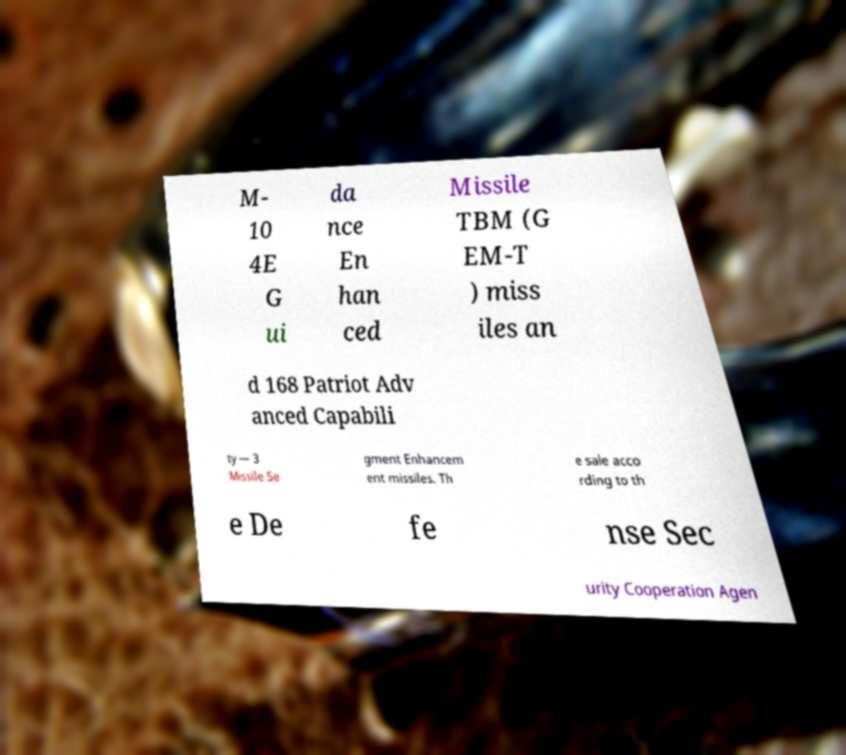Could you assist in decoding the text presented in this image and type it out clearly? M- 10 4E G ui da nce En han ced Missile TBM (G EM-T ) miss iles an d 168 Patriot Adv anced Capabili ty — 3 Missile Se gment Enhancem ent missiles. Th e sale acco rding to th e De fe nse Sec urity Cooperation Agen 